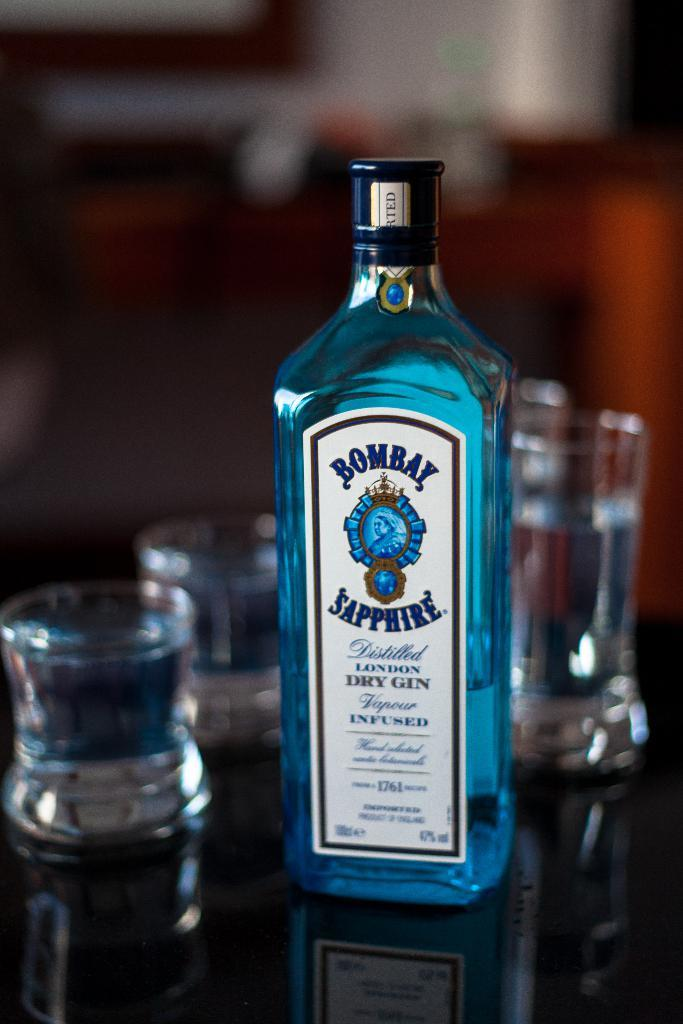What type of objects can be seen in the image? There are glasses and a bottle in the image. What is written on the bottle? The bottle has "Bombay Sapphire" written on it. What color is the liquid inside the bottle? The bottle contains a blue color liquid. What type of feast is being prepared in the image? There is no indication of a feast being prepared in the image; it only shows glasses and a bottle. Can you tell me who the mother is in the image? There is no person, let alone a mother, present in the image. 